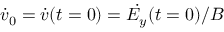<formula> <loc_0><loc_0><loc_500><loc_500>\dot { v } _ { 0 } = \dot { v } ( t = 0 ) = \dot { E _ { y } } ( t = 0 ) / B</formula> 